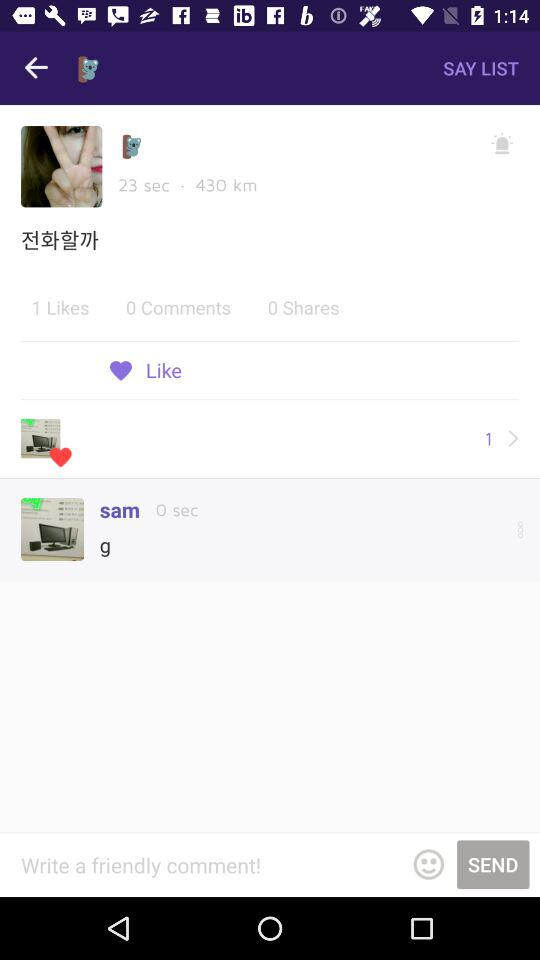How many more comments are there than shares?
Answer the question using a single word or phrase. 1 